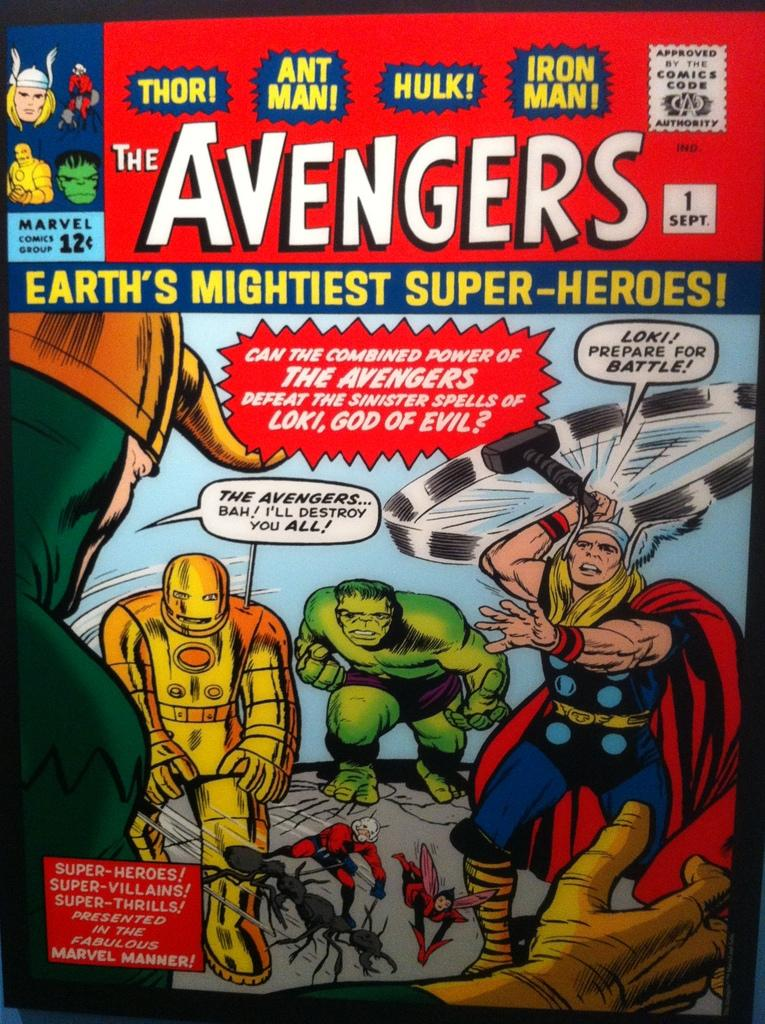<image>
Share a concise interpretation of the image provided. The front cover of an Avengers comic book 